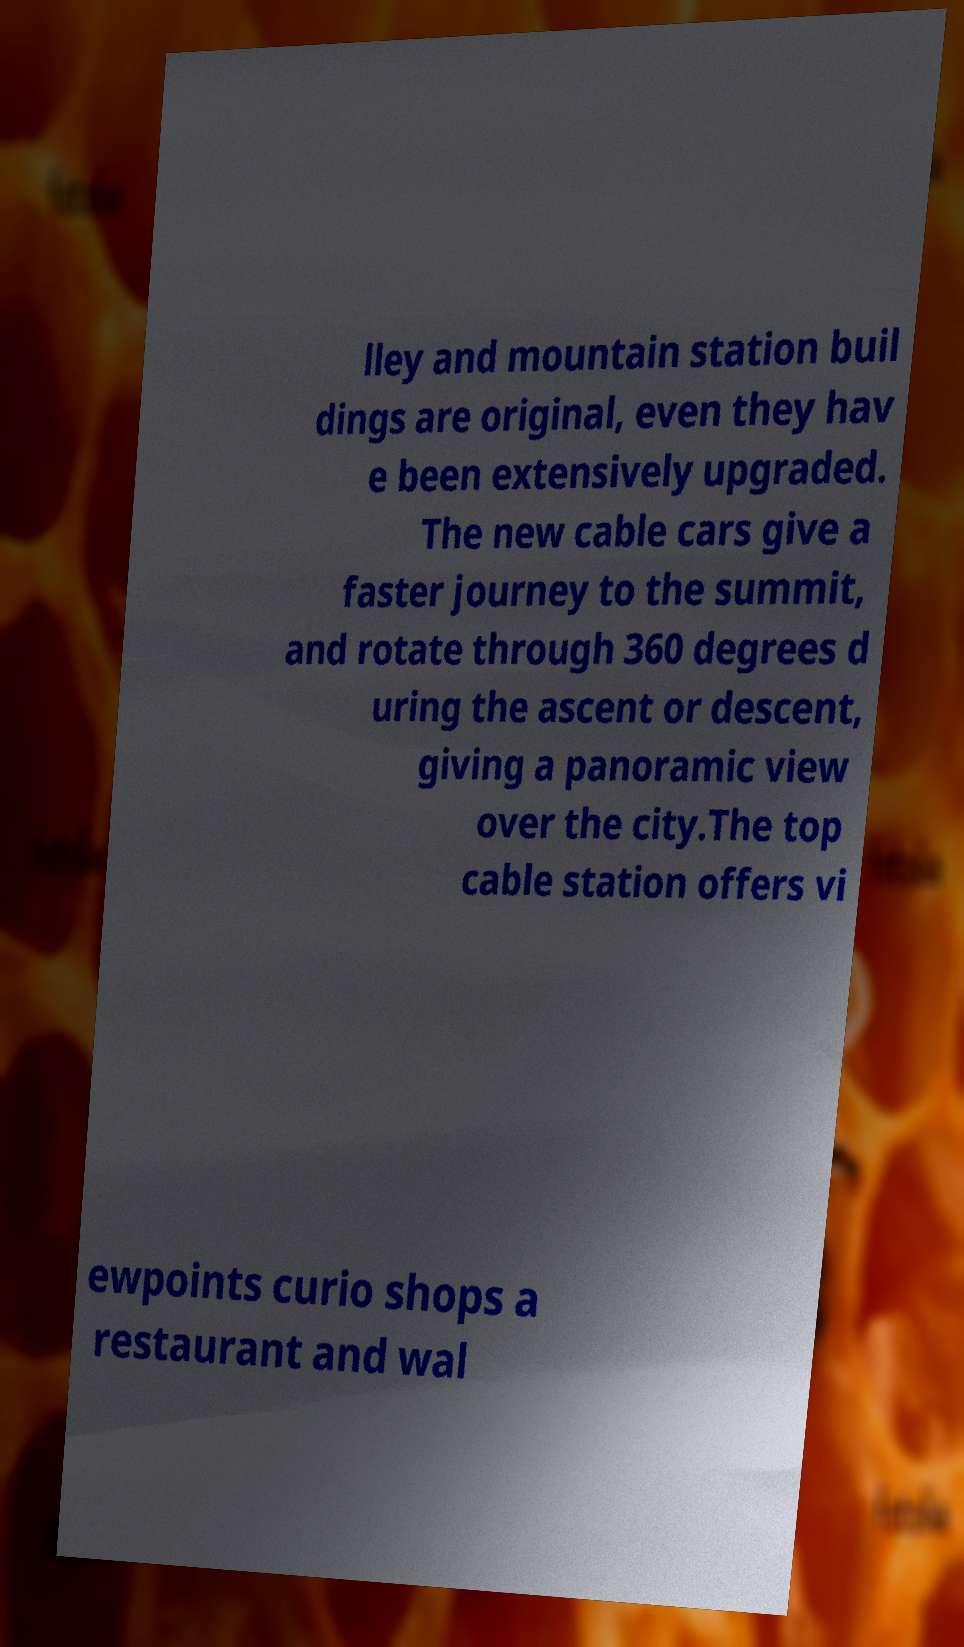Could you assist in decoding the text presented in this image and type it out clearly? lley and mountain station buil dings are original, even they hav e been extensively upgraded. The new cable cars give a faster journey to the summit, and rotate through 360 degrees d uring the ascent or descent, giving a panoramic view over the city.The top cable station offers vi ewpoints curio shops a restaurant and wal 